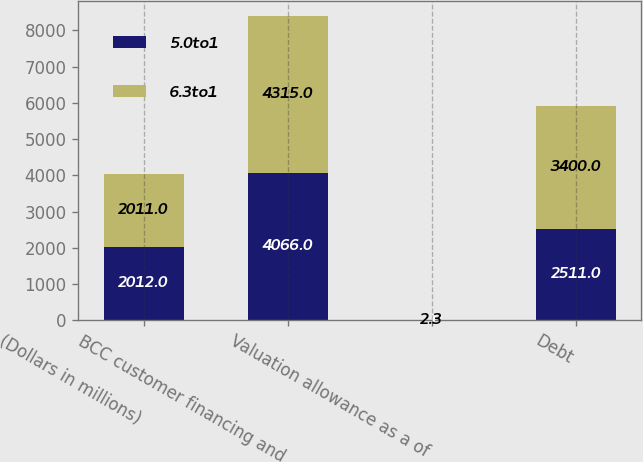Convert chart. <chart><loc_0><loc_0><loc_500><loc_500><stacked_bar_chart><ecel><fcel>(Dollars in millions)<fcel>BCC customer financing and<fcel>Valuation allowance as a of<fcel>Debt<nl><fcel>5.0to1<fcel>2012<fcel>4066<fcel>2<fcel>2511<nl><fcel>6.3to1<fcel>2011<fcel>4315<fcel>2.3<fcel>3400<nl></chart> 